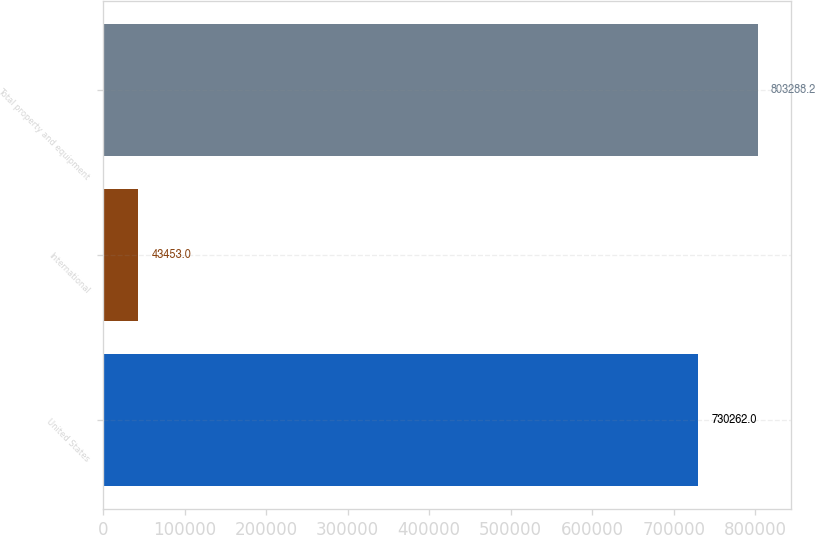<chart> <loc_0><loc_0><loc_500><loc_500><bar_chart><fcel>United States<fcel>International<fcel>Total property and equipment<nl><fcel>730262<fcel>43453<fcel>803288<nl></chart> 